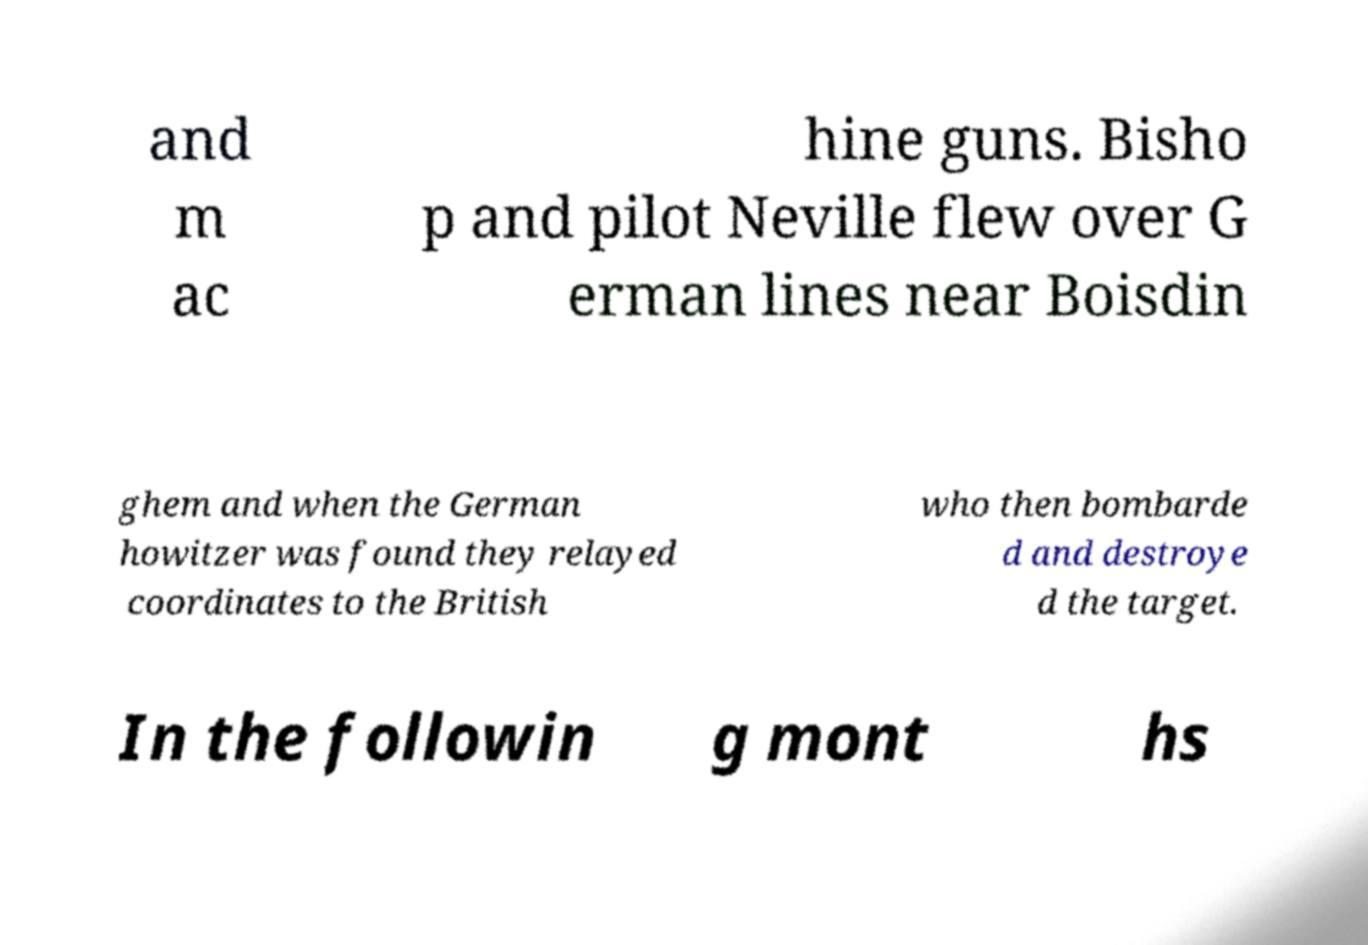There's text embedded in this image that I need extracted. Can you transcribe it verbatim? and m ac hine guns. Bisho p and pilot Neville flew over G erman lines near Boisdin ghem and when the German howitzer was found they relayed coordinates to the British who then bombarde d and destroye d the target. In the followin g mont hs 